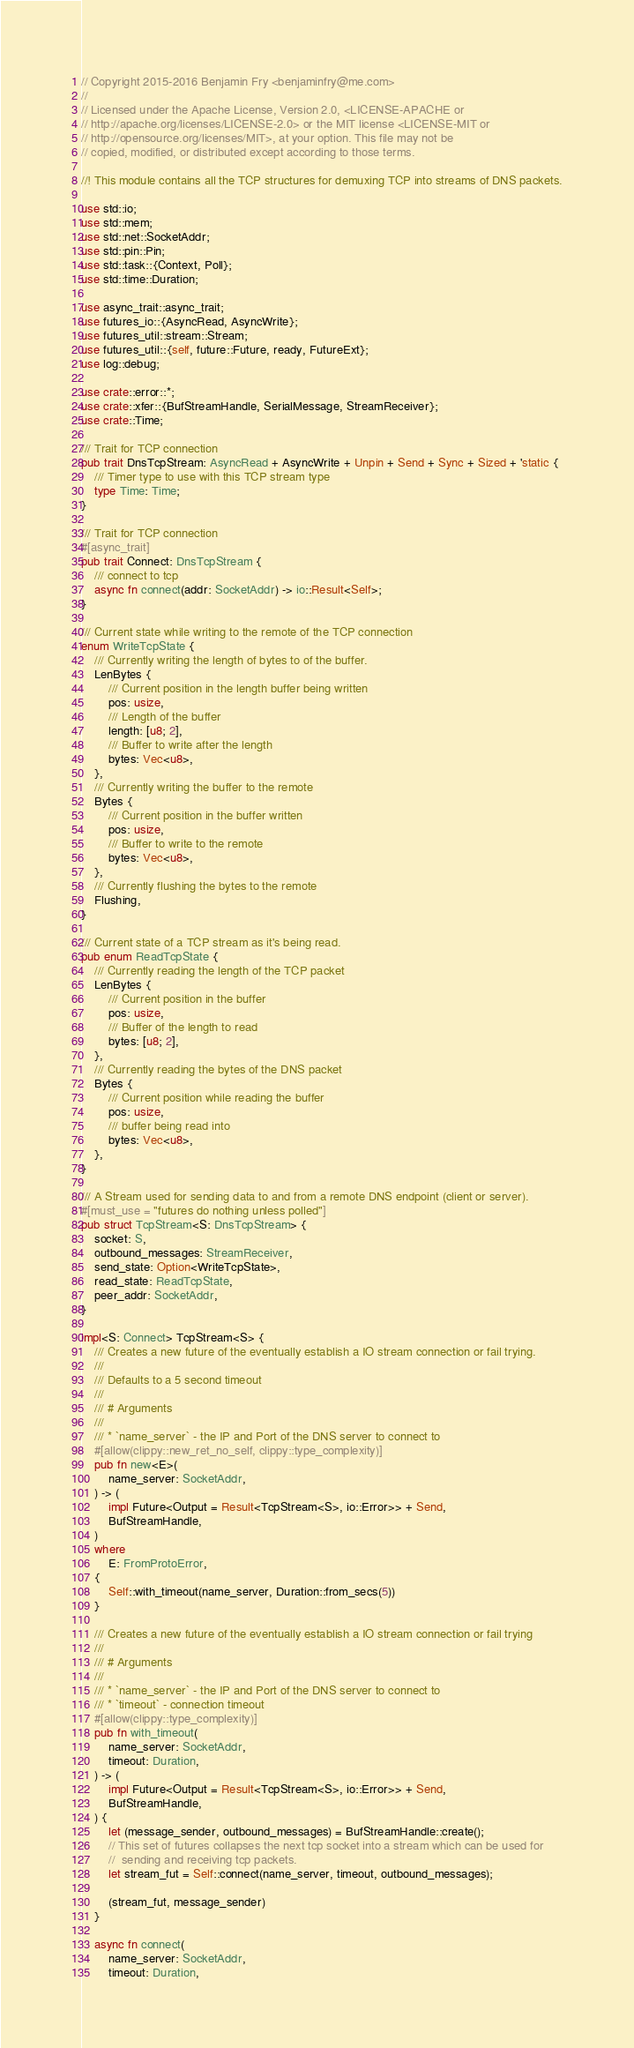<code> <loc_0><loc_0><loc_500><loc_500><_Rust_>// Copyright 2015-2016 Benjamin Fry <benjaminfry@me.com>
//
// Licensed under the Apache License, Version 2.0, <LICENSE-APACHE or
// http://apache.org/licenses/LICENSE-2.0> or the MIT license <LICENSE-MIT or
// http://opensource.org/licenses/MIT>, at your option. This file may not be
// copied, modified, or distributed except according to those terms.

//! This module contains all the TCP structures for demuxing TCP into streams of DNS packets.

use std::io;
use std::mem;
use std::net::SocketAddr;
use std::pin::Pin;
use std::task::{Context, Poll};
use std::time::Duration;

use async_trait::async_trait;
use futures_io::{AsyncRead, AsyncWrite};
use futures_util::stream::Stream;
use futures_util::{self, future::Future, ready, FutureExt};
use log::debug;

use crate::error::*;
use crate::xfer::{BufStreamHandle, SerialMessage, StreamReceiver};
use crate::Time;

/// Trait for TCP connection
pub trait DnsTcpStream: AsyncRead + AsyncWrite + Unpin + Send + Sync + Sized + 'static {
    /// Timer type to use with this TCP stream type
    type Time: Time;
}

/// Trait for TCP connection
#[async_trait]
pub trait Connect: DnsTcpStream {
    /// connect to tcp
    async fn connect(addr: SocketAddr) -> io::Result<Self>;
}

/// Current state while writing to the remote of the TCP connection
enum WriteTcpState {
    /// Currently writing the length of bytes to of the buffer.
    LenBytes {
        /// Current position in the length buffer being written
        pos: usize,
        /// Length of the buffer
        length: [u8; 2],
        /// Buffer to write after the length
        bytes: Vec<u8>,
    },
    /// Currently writing the buffer to the remote
    Bytes {
        /// Current position in the buffer written
        pos: usize,
        /// Buffer to write to the remote
        bytes: Vec<u8>,
    },
    /// Currently flushing the bytes to the remote
    Flushing,
}

/// Current state of a TCP stream as it's being read.
pub enum ReadTcpState {
    /// Currently reading the length of the TCP packet
    LenBytes {
        /// Current position in the buffer
        pos: usize,
        /// Buffer of the length to read
        bytes: [u8; 2],
    },
    /// Currently reading the bytes of the DNS packet
    Bytes {
        /// Current position while reading the buffer
        pos: usize,
        /// buffer being read into
        bytes: Vec<u8>,
    },
}

/// A Stream used for sending data to and from a remote DNS endpoint (client or server).
#[must_use = "futures do nothing unless polled"]
pub struct TcpStream<S: DnsTcpStream> {
    socket: S,
    outbound_messages: StreamReceiver,
    send_state: Option<WriteTcpState>,
    read_state: ReadTcpState,
    peer_addr: SocketAddr,
}

impl<S: Connect> TcpStream<S> {
    /// Creates a new future of the eventually establish a IO stream connection or fail trying.
    ///
    /// Defaults to a 5 second timeout
    ///
    /// # Arguments
    ///
    /// * `name_server` - the IP and Port of the DNS server to connect to
    #[allow(clippy::new_ret_no_self, clippy::type_complexity)]
    pub fn new<E>(
        name_server: SocketAddr,
    ) -> (
        impl Future<Output = Result<TcpStream<S>, io::Error>> + Send,
        BufStreamHandle,
    )
    where
        E: FromProtoError,
    {
        Self::with_timeout(name_server, Duration::from_secs(5))
    }

    /// Creates a new future of the eventually establish a IO stream connection or fail trying
    ///
    /// # Arguments
    ///
    /// * `name_server` - the IP and Port of the DNS server to connect to
    /// * `timeout` - connection timeout
    #[allow(clippy::type_complexity)]
    pub fn with_timeout(
        name_server: SocketAddr,
        timeout: Duration,
    ) -> (
        impl Future<Output = Result<TcpStream<S>, io::Error>> + Send,
        BufStreamHandle,
    ) {
        let (message_sender, outbound_messages) = BufStreamHandle::create();
        // This set of futures collapses the next tcp socket into a stream which can be used for
        //  sending and receiving tcp packets.
        let stream_fut = Self::connect(name_server, timeout, outbound_messages);

        (stream_fut, message_sender)
    }

    async fn connect(
        name_server: SocketAddr,
        timeout: Duration,</code> 